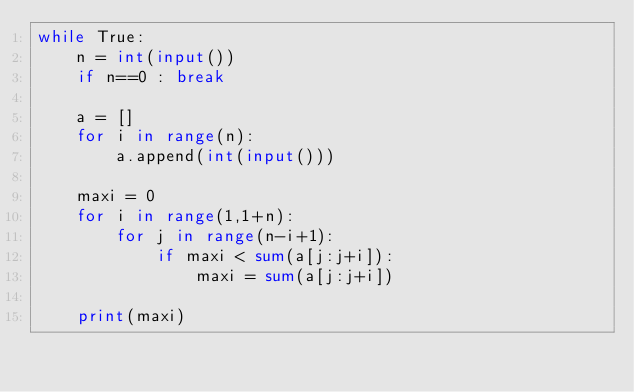<code> <loc_0><loc_0><loc_500><loc_500><_Python_>while True:
    n = int(input())
    if n==0 : break

    a = []
    for i in range(n):
        a.append(int(input()))

    maxi = 0
    for i in range(1,1+n):
        for j in range(n-i+1):
            if maxi < sum(a[j:j+i]):
                maxi = sum(a[j:j+i])

    print(maxi)</code> 